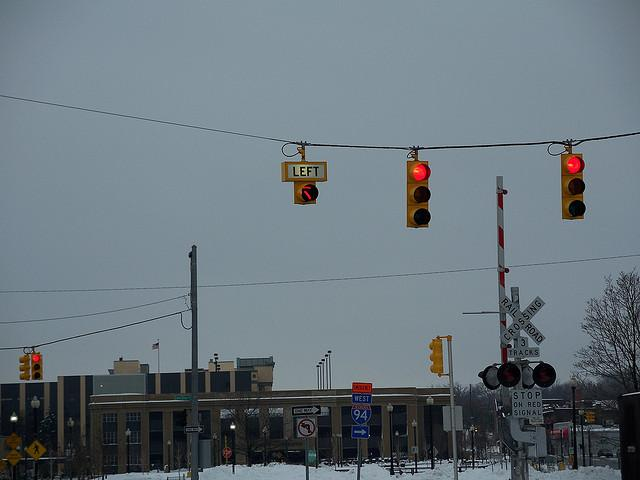What vehicle makes frequent crosses at this intersection? Please explain your reasoning. train. Trains cross at intersections like the one shown. 